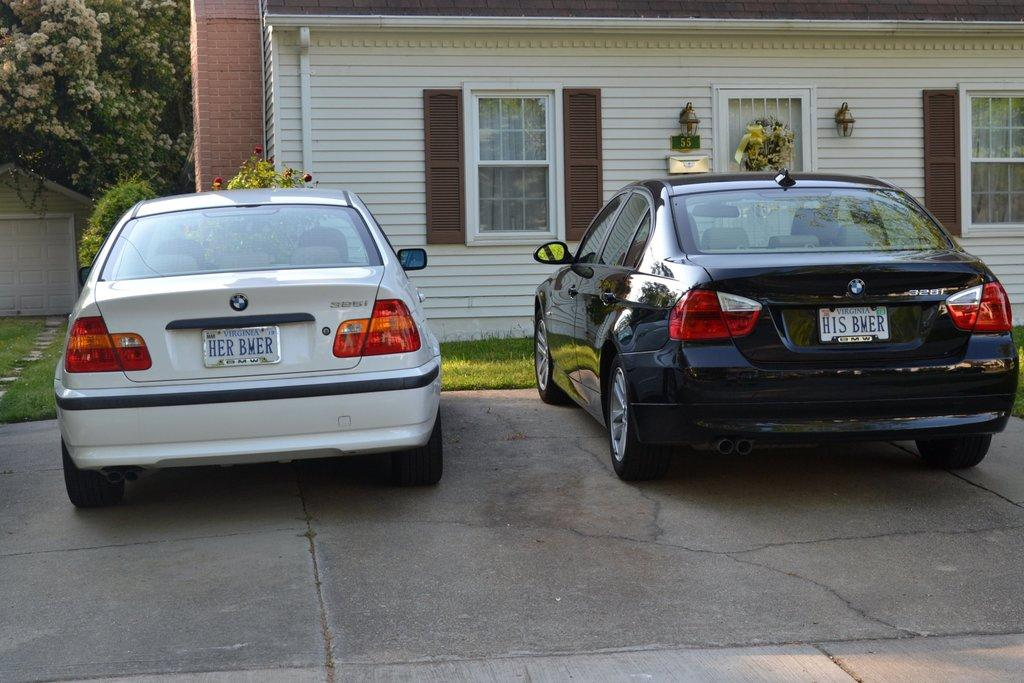<image>
Relay a brief, clear account of the picture shown. Two BMWs with Virginia license plates are parked next to each other. 